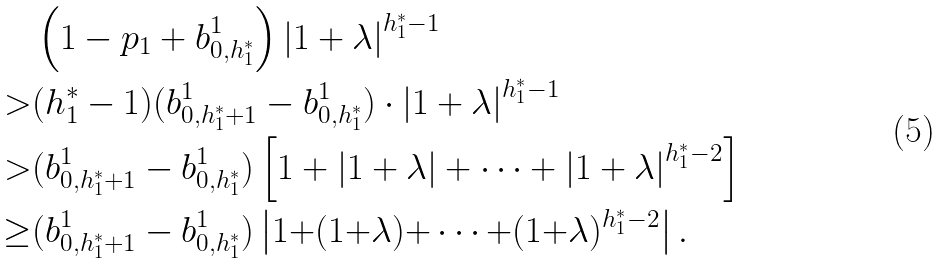Convert formula to latex. <formula><loc_0><loc_0><loc_500><loc_500>& \left ( 1 - p _ { 1 } + b ^ { 1 } _ { 0 , h ^ { * } _ { 1 } } \right ) \left | 1 + \lambda \right | ^ { h ^ { * } _ { 1 } - 1 } \\ > & ( h ^ { * } _ { 1 } - 1 ) ( b ^ { 1 } _ { 0 , h ^ { * } _ { 1 } + 1 } - b ^ { 1 } _ { 0 , h ^ { * } _ { 1 } } ) \cdot \left | 1 + \lambda \right | ^ { h ^ { * } _ { 1 } - 1 } \\ > & ( b ^ { 1 } _ { 0 , h ^ { * } _ { 1 } + 1 } - b ^ { 1 } _ { 0 , h ^ { * } _ { 1 } } ) \left [ 1 + \left | 1 + \lambda \right | + \cdots + \left | 1 + \lambda \right | ^ { h ^ { * } _ { 1 } - 2 } \right ] \\ \geq & ( b ^ { 1 } _ { 0 , h ^ { * } _ { 1 } + 1 } - b ^ { 1 } _ { 0 , h ^ { * } _ { 1 } } ) \left | 1 { + } ( 1 { + } \lambda ) { + } \cdots { + } ( 1 { + } \lambda ) ^ { h ^ { * } _ { 1 } { - } 2 } \right | .</formula> 